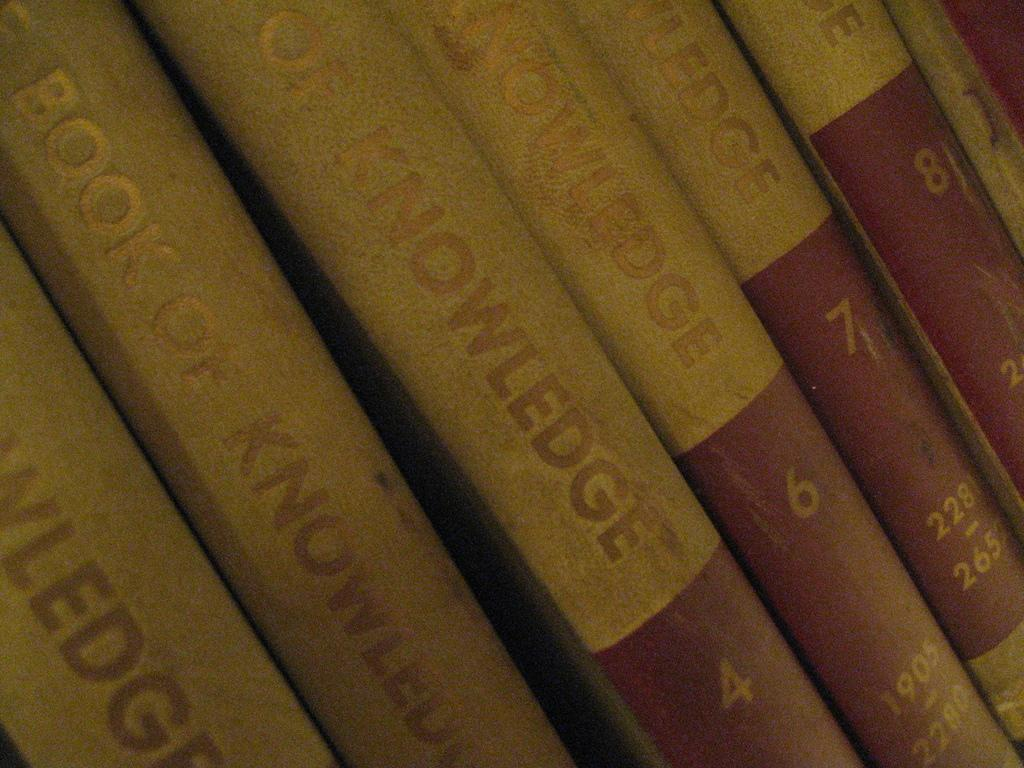<image>
Share a concise interpretation of the image provided. six copies of the encyclopedia titled "The Book of Knowledge". 